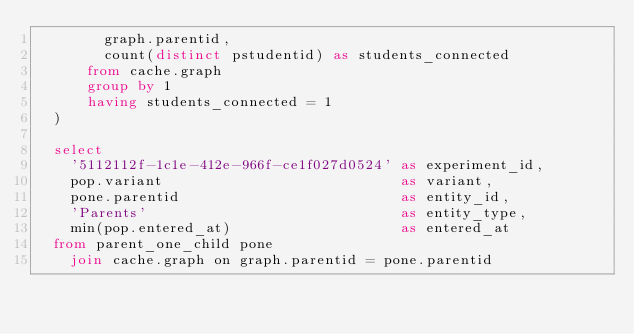Convert code to text. <code><loc_0><loc_0><loc_500><loc_500><_SQL_>        graph.parentid,
        count(distinct pstudentid) as students_connected
      from cache.graph
      group by 1
      having students_connected = 1
  )

  select
    '5112112f-1c1e-412e-966f-ce1f027d0524' as experiment_id,
    pop.variant                            as variant,
    pone.parentid                          as entity_id,
    'Parents'                              as entity_type,
    min(pop.entered_at)                    as entered_at
  from parent_one_child pone
    join cache.graph on graph.parentid = pone.parentid</code> 